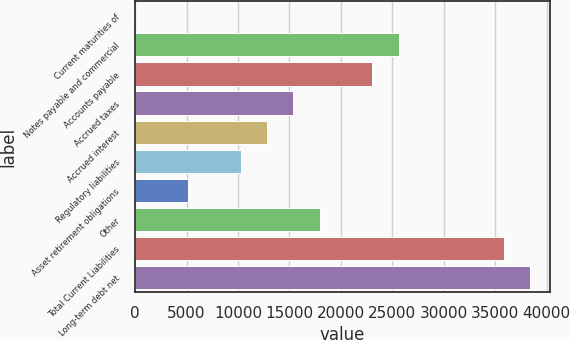<chart> <loc_0><loc_0><loc_500><loc_500><bar_chart><fcel>Current maturities of<fcel>Notes payable and commercial<fcel>Accounts payable<fcel>Accrued taxes<fcel>Accrued interest<fcel>Regulatory liabilities<fcel>Asset retirement obligations<fcel>Other<fcel>Total Current Liabilities<fcel>Long-term debt net<nl><fcel>30.3<fcel>25598.1<fcel>23041.3<fcel>15371<fcel>12814.2<fcel>10257.4<fcel>5143.86<fcel>17927.8<fcel>35825.2<fcel>38382<nl></chart> 